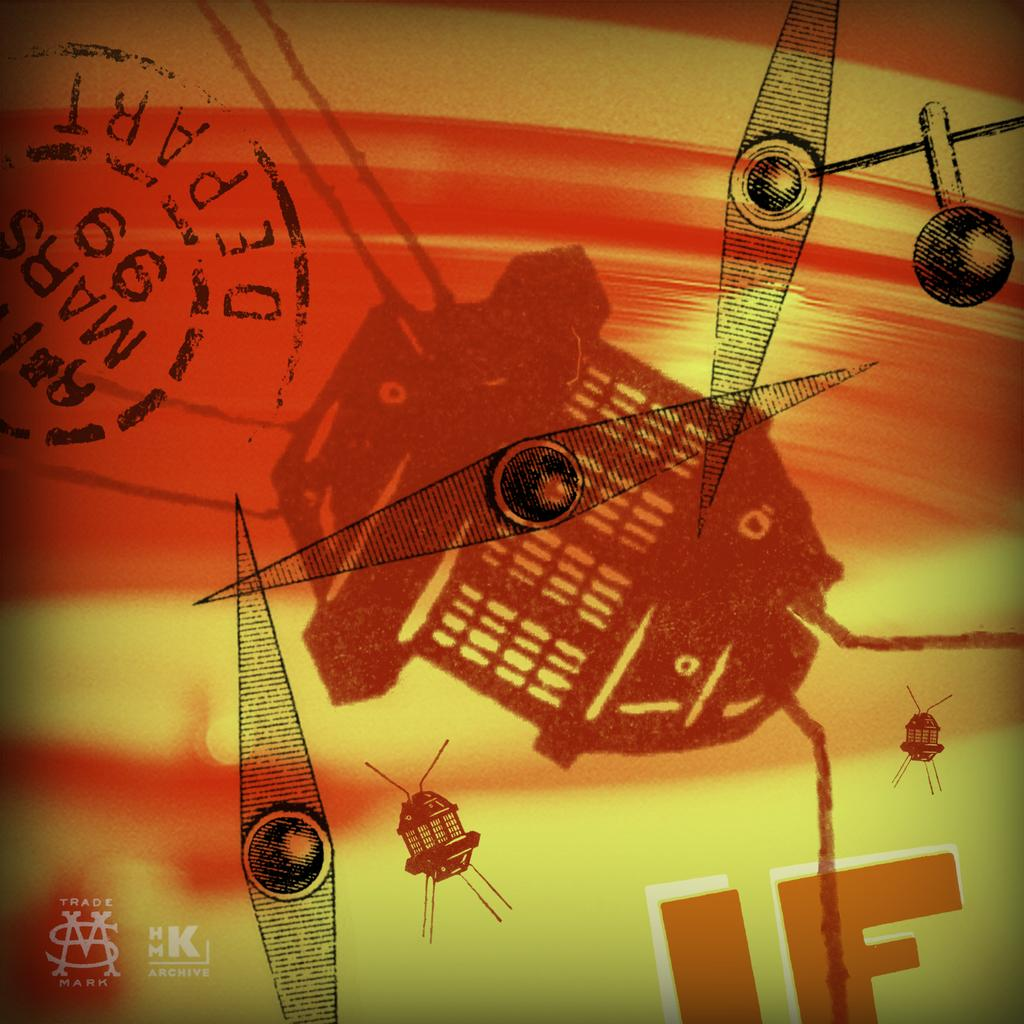What is located in the top left of the image? There is a stamp seal in the top left of the image. What else can be seen in the image besides the stamp seal? There is a logo, some text, and a few objects in the image. Can you describe the logo in the image? Unfortunately, the facts provided do not give a detailed description of the logo. What type of information might be conveyed by the text in the image? The text in the image might convey information about the objects or the purpose of the image. How many pigs are visible in the image? There are no pigs present in the image. What is the weight of the objects in the image? The facts provided do not give any information about the weight of the objects in the image. 